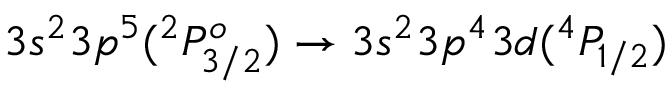<formula> <loc_0><loc_0><loc_500><loc_500>3 s ^ { 2 } 3 p ^ { 5 } ( ^ { 2 } P _ { 3 / 2 } ^ { o } ) \rightarrow 3 s ^ { 2 } 3 p ^ { 4 } 3 d ( ^ { 4 } P _ { 1 / 2 } )</formula> 